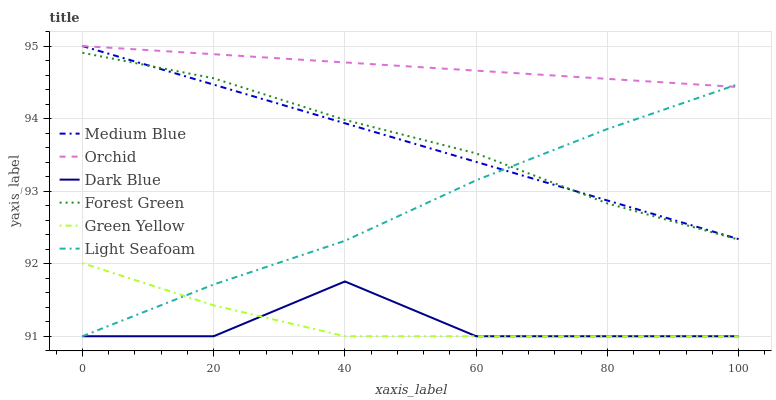Does Dark Blue have the minimum area under the curve?
Answer yes or no. Yes. Does Orchid have the maximum area under the curve?
Answer yes or no. Yes. Does Medium Blue have the minimum area under the curve?
Answer yes or no. No. Does Medium Blue have the maximum area under the curve?
Answer yes or no. No. Is Orchid the smoothest?
Answer yes or no. Yes. Is Dark Blue the roughest?
Answer yes or no. Yes. Is Medium Blue the smoothest?
Answer yes or no. No. Is Medium Blue the roughest?
Answer yes or no. No. Does Light Seafoam have the lowest value?
Answer yes or no. Yes. Does Medium Blue have the lowest value?
Answer yes or no. No. Does Orchid have the highest value?
Answer yes or no. Yes. Does Dark Blue have the highest value?
Answer yes or no. No. Is Dark Blue less than Forest Green?
Answer yes or no. Yes. Is Orchid greater than Green Yellow?
Answer yes or no. Yes. Does Medium Blue intersect Light Seafoam?
Answer yes or no. Yes. Is Medium Blue less than Light Seafoam?
Answer yes or no. No. Is Medium Blue greater than Light Seafoam?
Answer yes or no. No. Does Dark Blue intersect Forest Green?
Answer yes or no. No. 